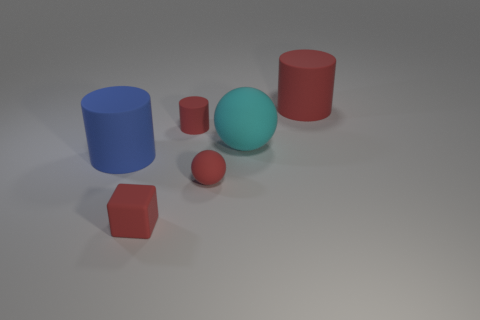Add 2 small blocks. How many objects exist? 8 Subtract all cubes. How many objects are left? 5 Subtract 0 yellow balls. How many objects are left? 6 Subtract all big blue cylinders. Subtract all large yellow rubber things. How many objects are left? 5 Add 6 cyan things. How many cyan things are left? 7 Add 4 red matte cylinders. How many red matte cylinders exist? 6 